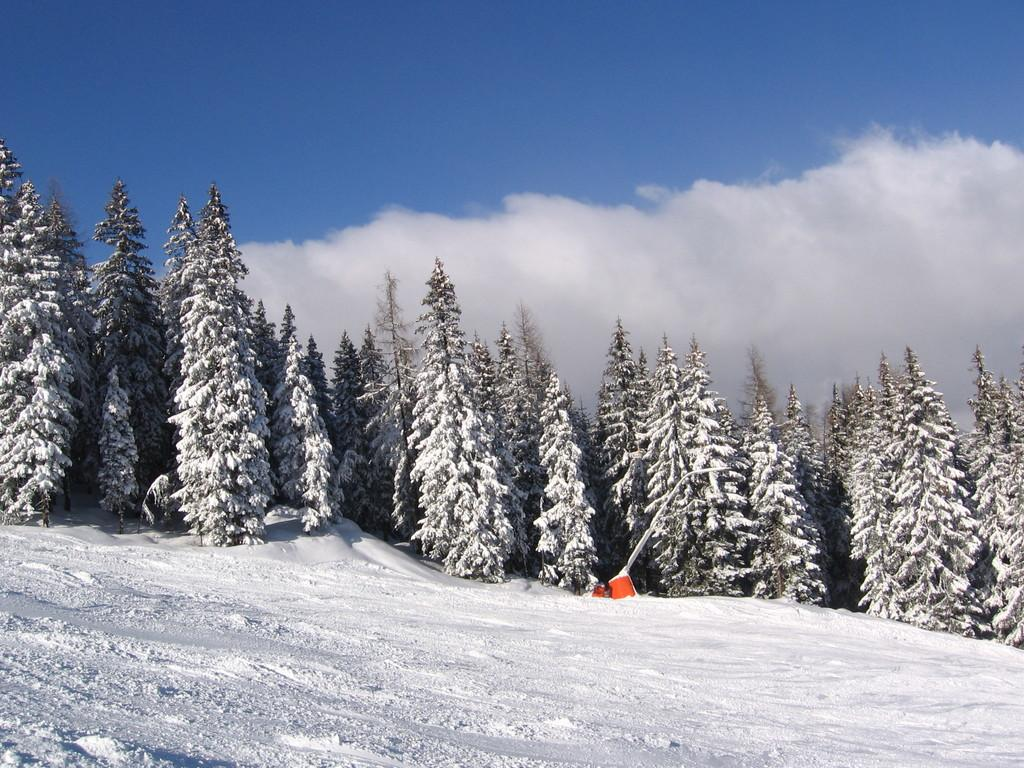What type of weather is depicted in the image? There is snow in the image, which suggests cold weather. What can be seen in the background of the image? There are trees in the background of the image. What is visible in the sky in the image? Clouds are visible in the sky in the image. How many cherries are hanging from the trees in the image? There is no mention of cherries in the image; it features snow, trees, and clouds in the sky. What type of ring can be seen on the snow in the image? There is no ring present on the snow in the image. 